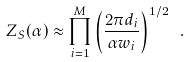Convert formula to latex. <formula><loc_0><loc_0><loc_500><loc_500>Z _ { S } ( \alpha ) \approx \prod _ { i = 1 } ^ { M } \left ( \frac { 2 \pi d _ { i } } { \alpha w _ { i } } \right ) ^ { 1 / 2 } \ .</formula> 